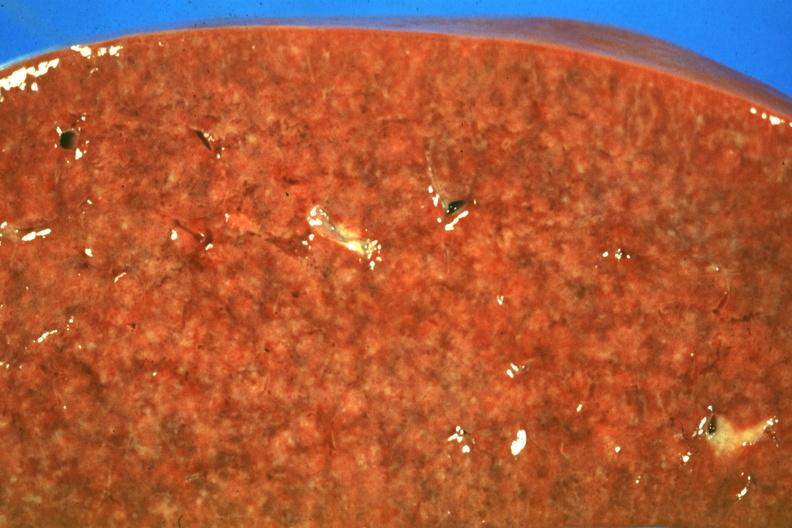s sarcoidosis present?
Answer the question using a single word or phrase. Yes 